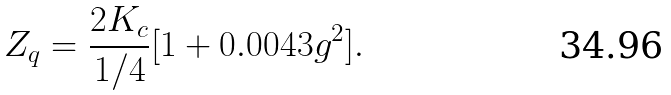Convert formula to latex. <formula><loc_0><loc_0><loc_500><loc_500>Z _ { q } = \frac { 2 K _ { c } } { 1 / 4 } [ 1 + 0 . 0 0 4 3 g ^ { 2 } ] .</formula> 